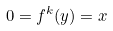<formula> <loc_0><loc_0><loc_500><loc_500>0 = f ^ { k } ( y ) = x</formula> 